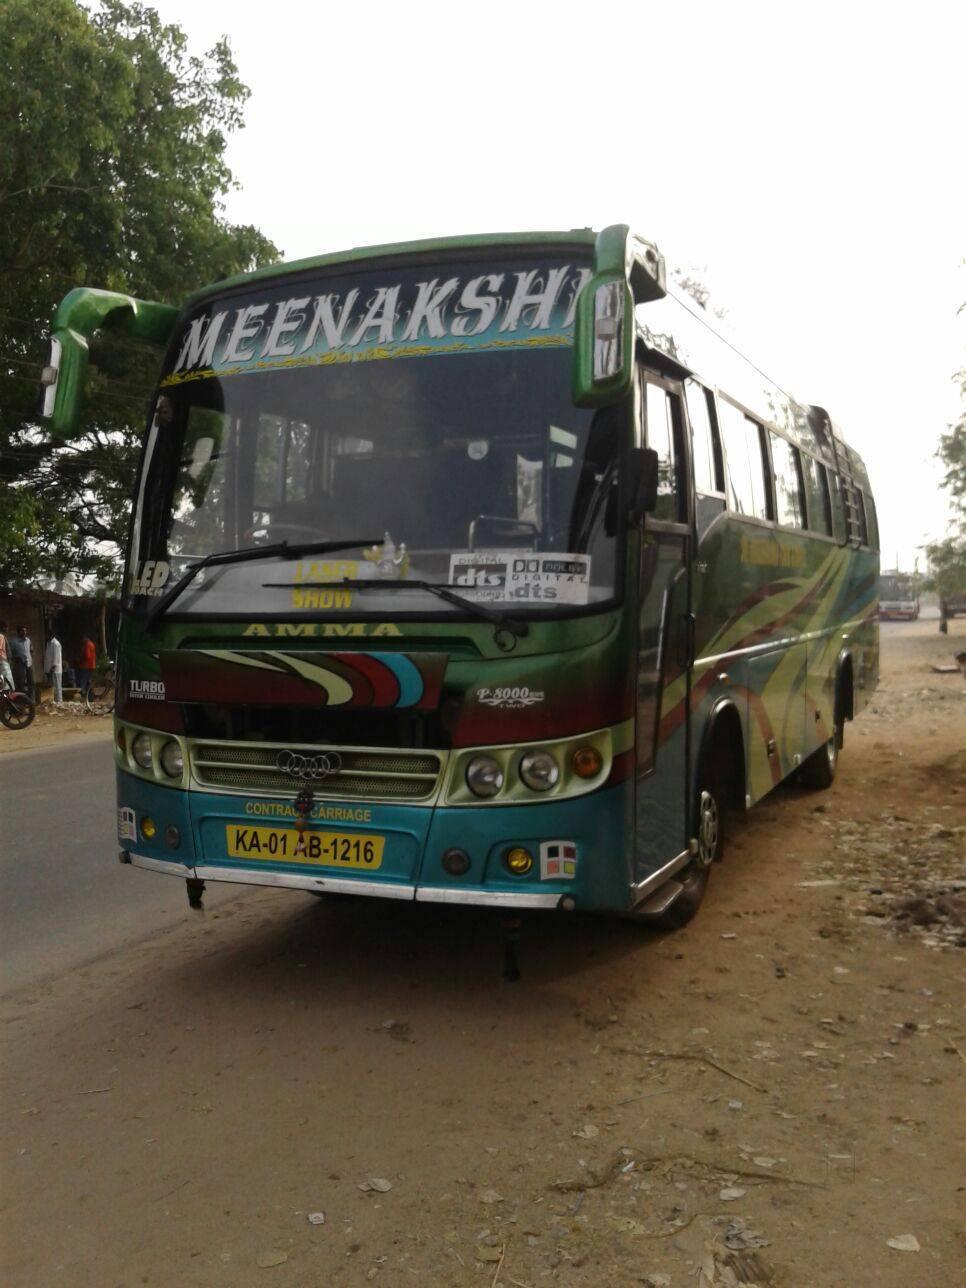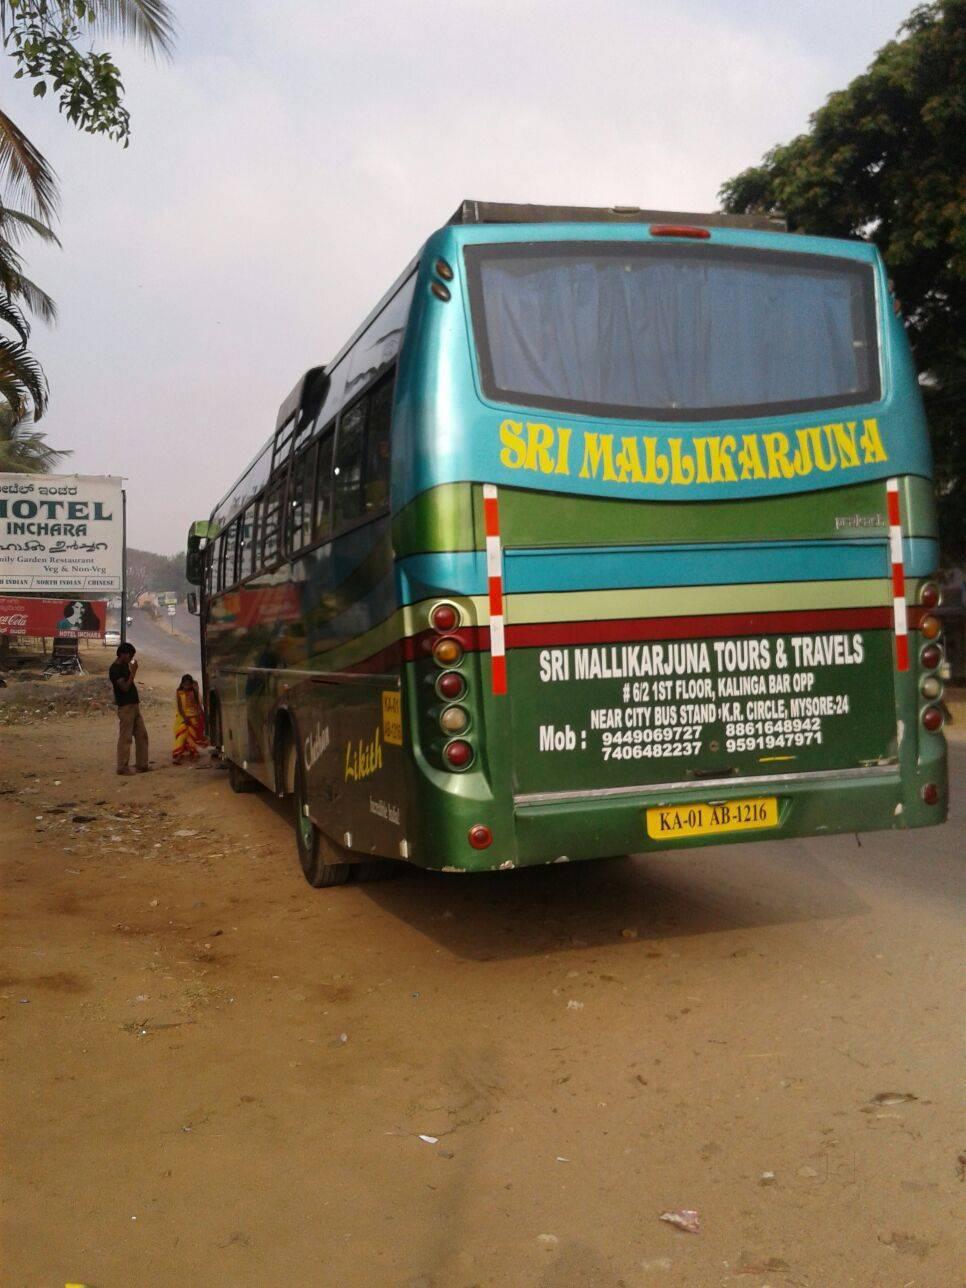The first image is the image on the left, the second image is the image on the right. For the images shown, is this caption "The left and right image contains the same number of travel buses." true? Answer yes or no. Yes. The first image is the image on the left, the second image is the image on the right. Analyze the images presented: Is the assertion "The left image shows one primarily white bus with a flat, slightly sloped front displayed at an angle facing rightward." valid? Answer yes or no. No. 